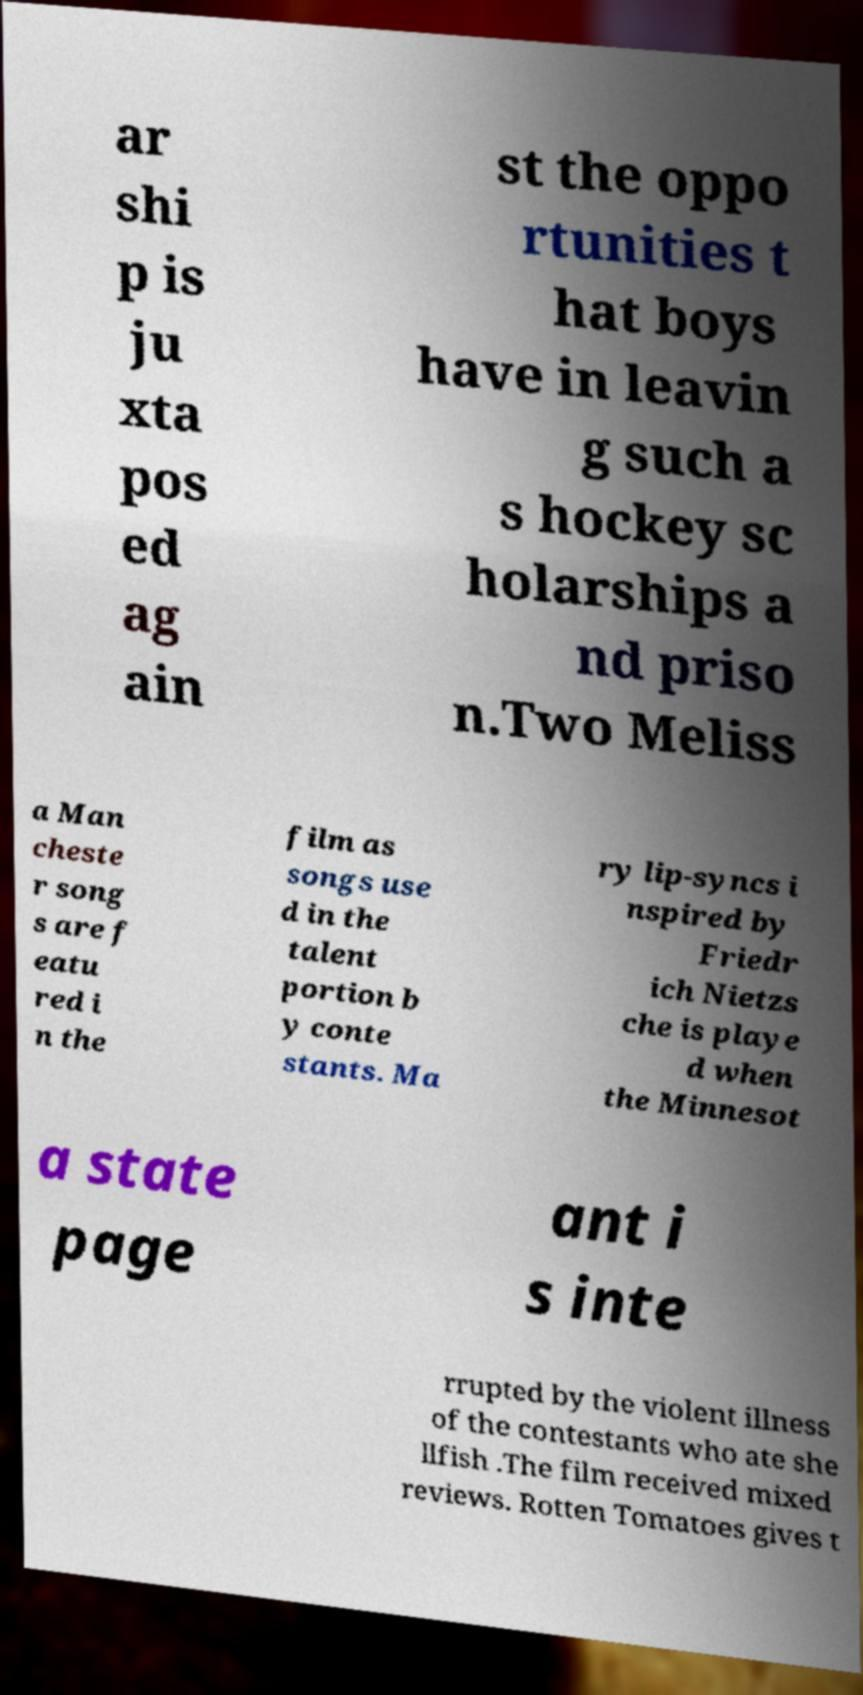Could you assist in decoding the text presented in this image and type it out clearly? ar shi p is ju xta pos ed ag ain st the oppo rtunities t hat boys have in leavin g such a s hockey sc holarships a nd priso n.Two Meliss a Man cheste r song s are f eatu red i n the film as songs use d in the talent portion b y conte stants. Ma ry lip-syncs i nspired by Friedr ich Nietzs che is playe d when the Minnesot a state page ant i s inte rrupted by the violent illness of the contestants who ate she llfish .The film received mixed reviews. Rotten Tomatoes gives t 